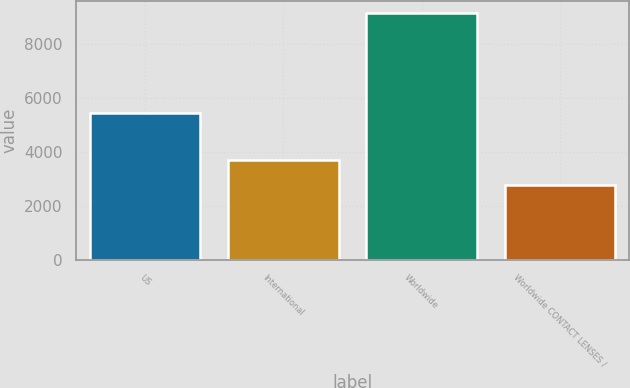<chart> <loc_0><loc_0><loc_500><loc_500><bar_chart><fcel>US<fcel>International<fcel>Worldwide<fcel>Worldwide CONTACT LENSES /<nl><fcel>5438<fcel>3690<fcel>9128<fcel>2785<nl></chart> 